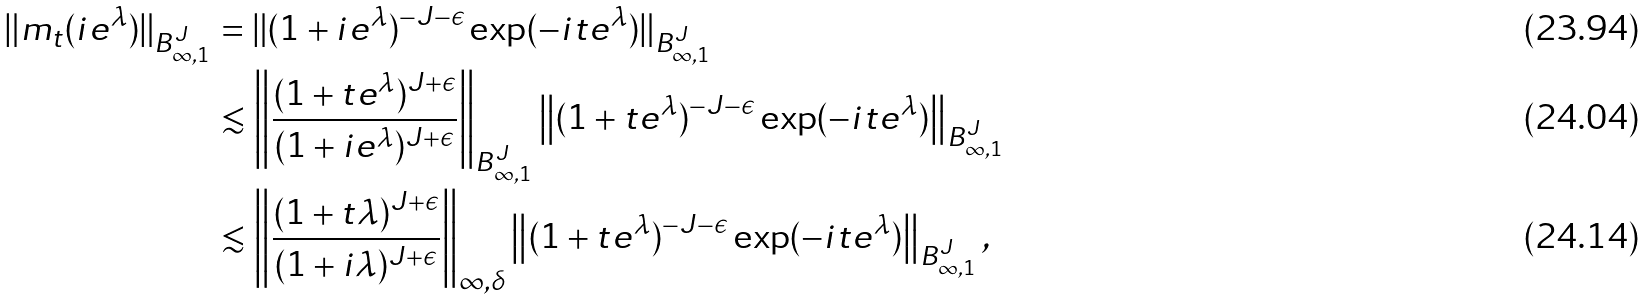<formula> <loc_0><loc_0><loc_500><loc_500>\| m _ { t } ( i e ^ { \lambda } ) \| _ { B ^ { J } _ { \infty , 1 } } & = \| ( 1 + i e ^ { \lambda } ) ^ { - J - \epsilon } \exp ( - i t e ^ { \lambda } ) \| _ { B ^ { J } _ { \infty , 1 } } \\ & \lesssim \left \| \frac { ( 1 + t e ^ { \lambda } ) ^ { J + \epsilon } } { ( 1 + i e ^ { \lambda } ) ^ { J + \epsilon } } \right \| _ { B ^ { J } _ { \infty , 1 } } \left \| ( 1 + t e ^ { \lambda } ) ^ { - J - \epsilon } \exp ( - i t e ^ { \lambda } ) \right \| _ { B ^ { J } _ { \infty , 1 } } \\ & \lesssim \left \| \frac { ( 1 + t \lambda ) ^ { J + \epsilon } } { ( 1 + i \lambda ) ^ { J + \epsilon } } \right \| _ { \infty , \delta } \left \| ( 1 + t e ^ { \lambda } ) ^ { - J - \epsilon } \exp ( - i t e ^ { \lambda } ) \right \| _ { B ^ { J } _ { \infty , 1 } } ,</formula> 